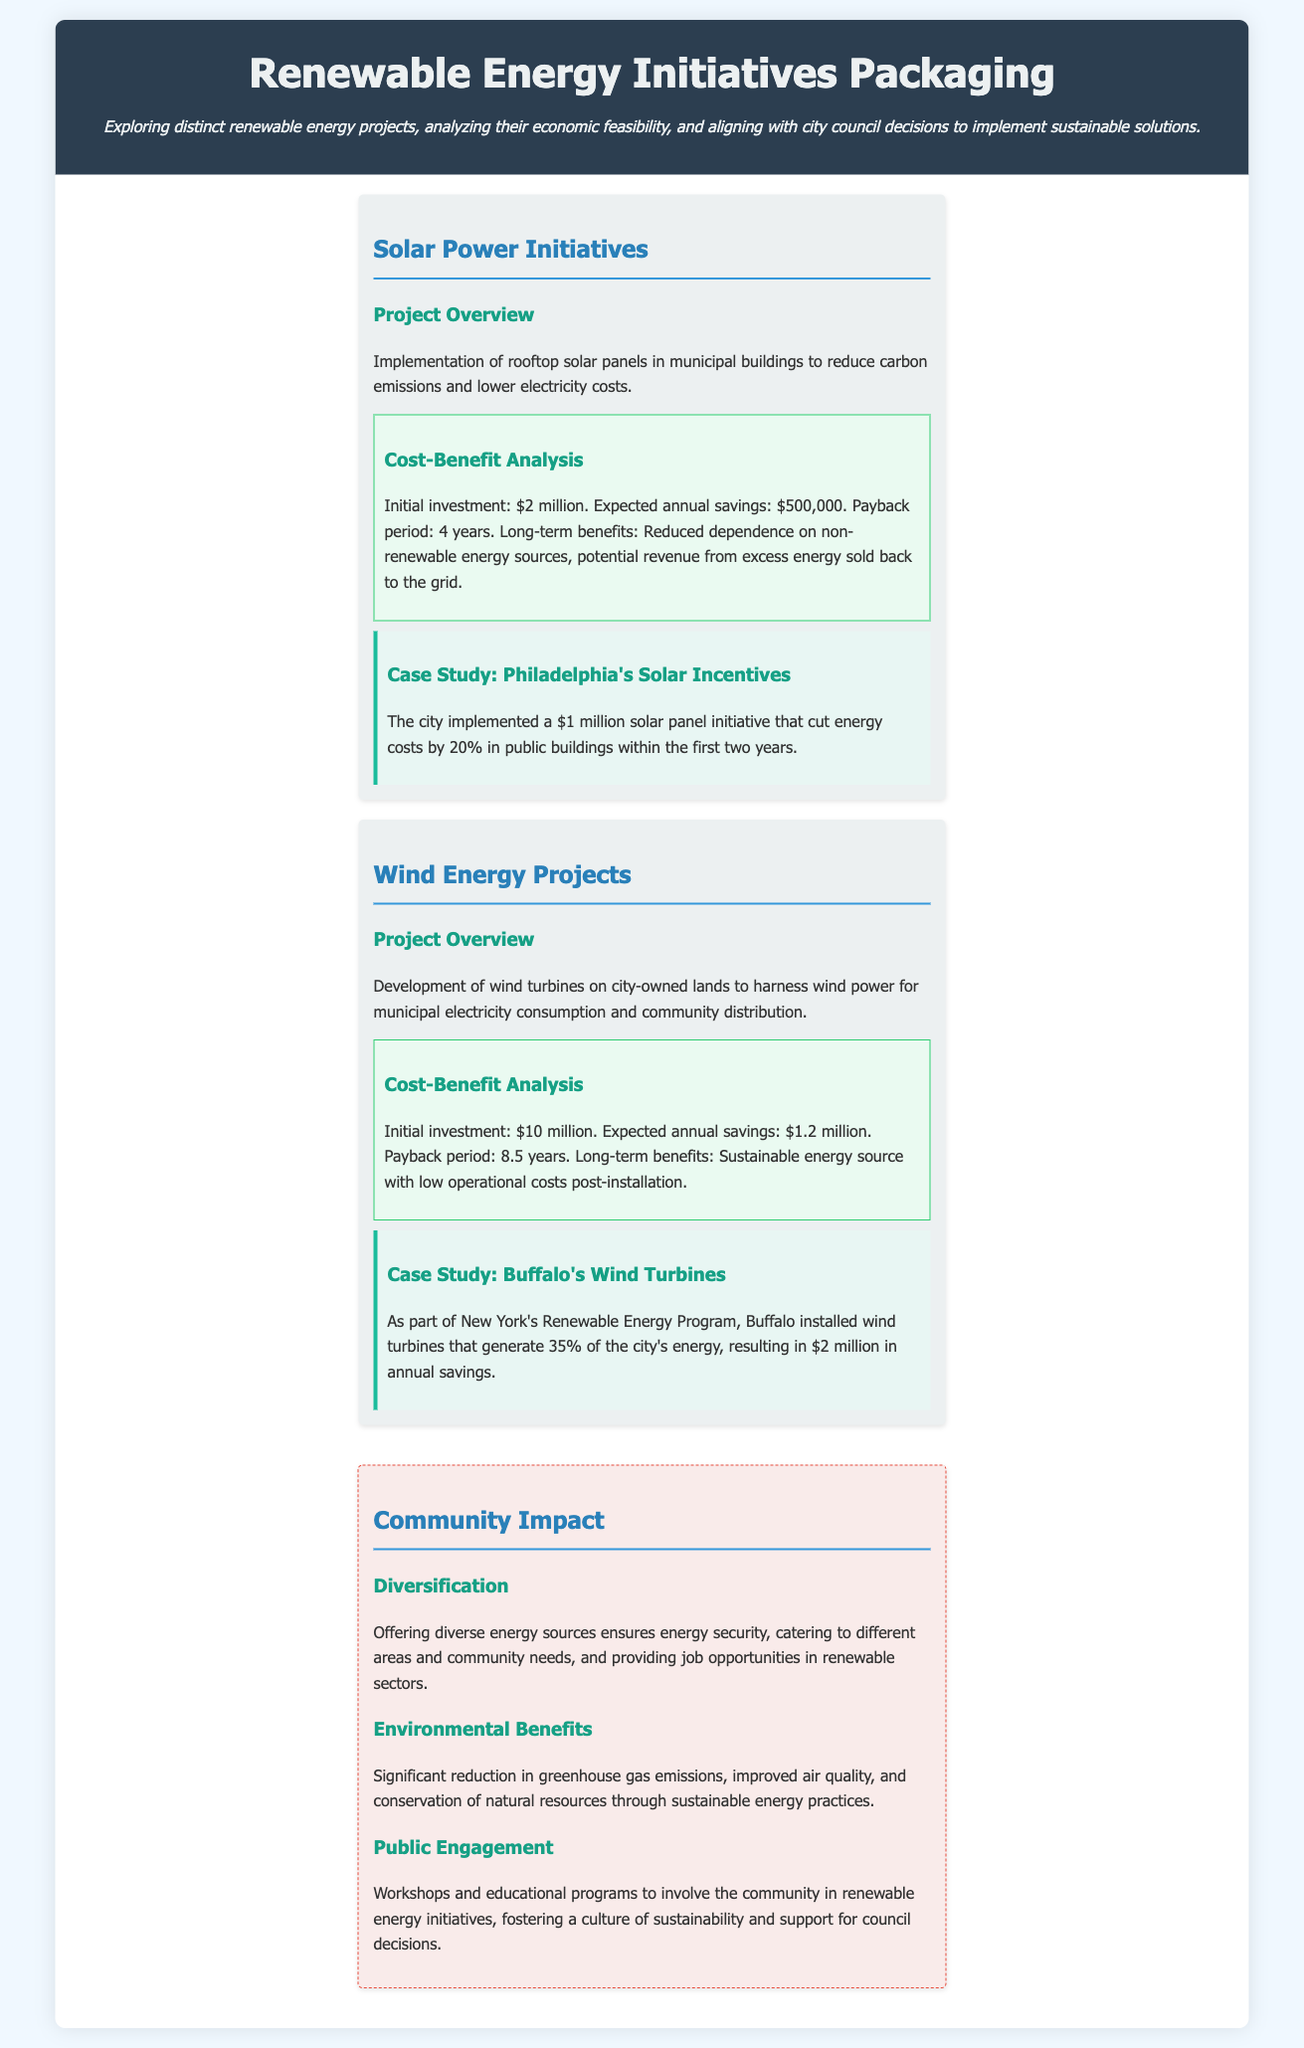what is the initial investment for solar power initiatives? The document states that the initial investment for solar power initiatives is $2 million.
Answer: $2 million what is the expected annual savings from wind energy projects? According to the document, the expected annual savings from wind energy projects is $1.2 million.
Answer: $1.2 million how long is the payback period for the solar power initiatives? The document mentions that the payback period for the solar power initiatives is 4 years.
Answer: 4 years what are the environmental benefits highlighted in the document? The document states that significant reduction in greenhouse gas emissions, improved air quality, and conservation of natural resources are the environmental benefits.
Answer: reduction in greenhouse gas emissions, improved air quality, conservation of natural resources which city is cited as a case study for solar incentives? The document cites Philadelphia as the city for the case study on solar incentives.
Answer: Philadelphia what percentage of Buffalo's energy is generated by wind turbines? The document indicates that Buffalo's wind turbines generate 35% of the city's energy.
Answer: 35% what is a long-term benefit of solar power initiatives listed in the document? The document lists reduced dependence on non-renewable energy sources as a long-term benefit of solar power initiatives.
Answer: reduced dependence on non-renewable energy sources how does the document suggest involving the community? The document suggests involving the community through workshops and educational programs.
Answer: workshops and educational programs 